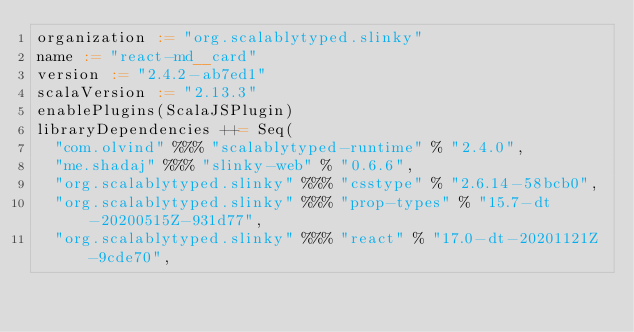<code> <loc_0><loc_0><loc_500><loc_500><_Scala_>organization := "org.scalablytyped.slinky"
name := "react-md__card"
version := "2.4.2-ab7ed1"
scalaVersion := "2.13.3"
enablePlugins(ScalaJSPlugin)
libraryDependencies ++= Seq(
  "com.olvind" %%% "scalablytyped-runtime" % "2.4.0",
  "me.shadaj" %%% "slinky-web" % "0.6.6",
  "org.scalablytyped.slinky" %%% "csstype" % "2.6.14-58bcb0",
  "org.scalablytyped.slinky" %%% "prop-types" % "15.7-dt-20200515Z-931d77",
  "org.scalablytyped.slinky" %%% "react" % "17.0-dt-20201121Z-9cde70",</code> 